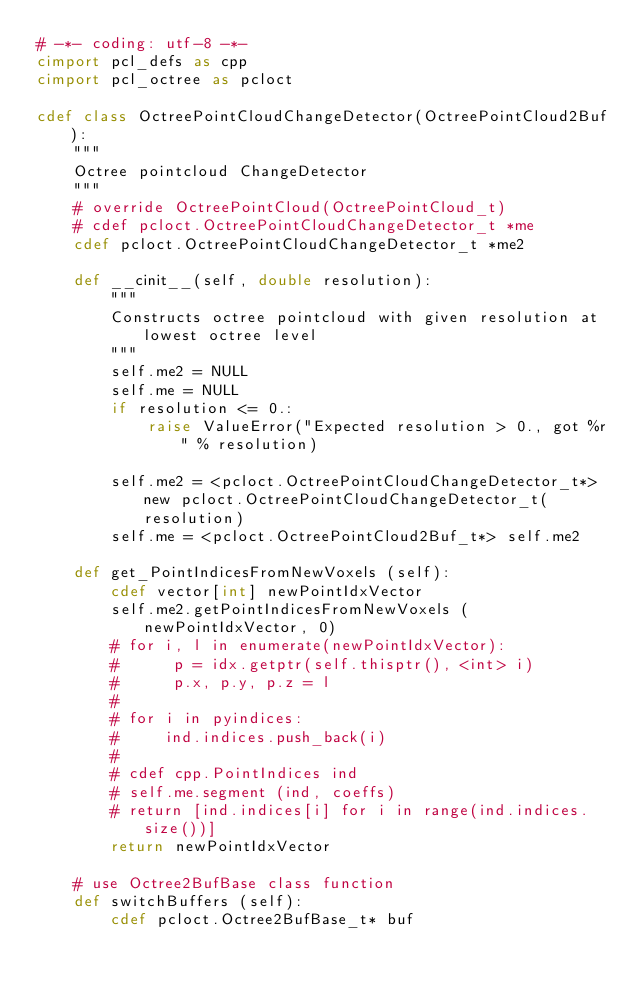<code> <loc_0><loc_0><loc_500><loc_500><_Cython_># -*- coding: utf-8 -*-
cimport pcl_defs as cpp
cimport pcl_octree as pcloct

cdef class OctreePointCloudChangeDetector(OctreePointCloud2Buf):
    """
    Octree pointcloud ChangeDetector
    """
    # override OctreePointCloud(OctreePointCloud_t)
    # cdef pcloct.OctreePointCloudChangeDetector_t *me
    cdef pcloct.OctreePointCloudChangeDetector_t *me2

    def __cinit__(self, double resolution):
        """
        Constructs octree pointcloud with given resolution at lowest octree level
        """ 
        self.me2 = NULL
        self.me = NULL
        if resolution <= 0.:
            raise ValueError("Expected resolution > 0., got %r" % resolution)

        self.me2 = <pcloct.OctreePointCloudChangeDetector_t*> new pcloct.OctreePointCloudChangeDetector_t(resolution)
        self.me = <pcloct.OctreePointCloud2Buf_t*> self.me2

    def get_PointIndicesFromNewVoxels (self):
        cdef vector[int] newPointIdxVector
        self.me2.getPointIndicesFromNewVoxels (newPointIdxVector, 0)
        # for i, l in enumerate(newPointIdxVector):
        #      p = idx.getptr(self.thisptr(), <int> i)
        #      p.x, p.y, p.z = l
        # 
        # for i in pyindices:
        #     ind.indices.push_back(i)
        # 
        # cdef cpp.PointIndices ind
        # self.me.segment (ind, coeffs)
        # return [ind.indices[i] for i in range(ind.indices.size())]
        return newPointIdxVector

    # use Octree2BufBase class function
    def switchBuffers (self):
        cdef pcloct.Octree2BufBase_t* buf</code> 